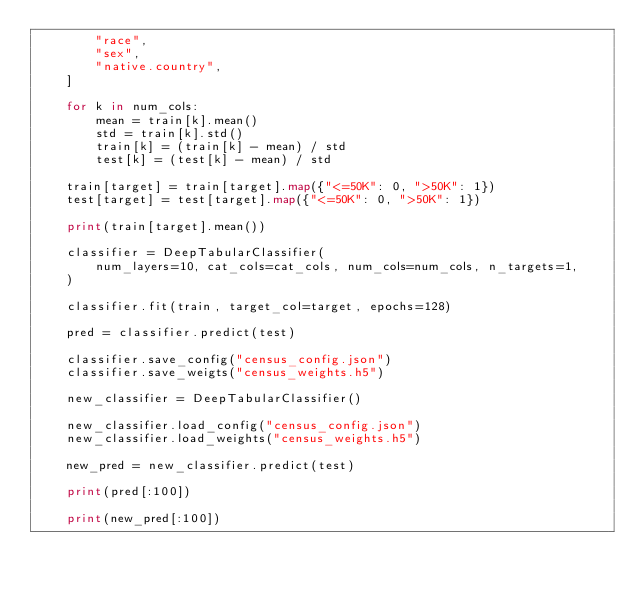Convert code to text. <code><loc_0><loc_0><loc_500><loc_500><_Python_>        "race",
        "sex",
        "native.country",
    ]

    for k in num_cols:
        mean = train[k].mean()
        std = train[k].std()
        train[k] = (train[k] - mean) / std
        test[k] = (test[k] - mean) / std

    train[target] = train[target].map({"<=50K": 0, ">50K": 1})
    test[target] = test[target].map({"<=50K": 0, ">50K": 1})

    print(train[target].mean())

    classifier = DeepTabularClassifier(
        num_layers=10, cat_cols=cat_cols, num_cols=num_cols, n_targets=1,
    )

    classifier.fit(train, target_col=target, epochs=128)

    pred = classifier.predict(test)

    classifier.save_config("census_config.json")
    classifier.save_weigts("census_weights.h5")

    new_classifier = DeepTabularClassifier()

    new_classifier.load_config("census_config.json")
    new_classifier.load_weights("census_weights.h5")

    new_pred = new_classifier.predict(test)

    print(pred[:100])

    print(new_pred[:100])
</code> 